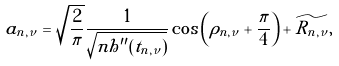<formula> <loc_0><loc_0><loc_500><loc_500>a _ { n , \nu } = \sqrt { \frac { 2 } { \pi } } \frac { 1 } { \sqrt { n h ^ { \prime \prime } ( t _ { n , \nu } ) } } \cos \left ( \rho _ { n , \nu } + \frac { \pi } { 4 } \right ) + \widetilde { R _ { n , \nu } } ,</formula> 